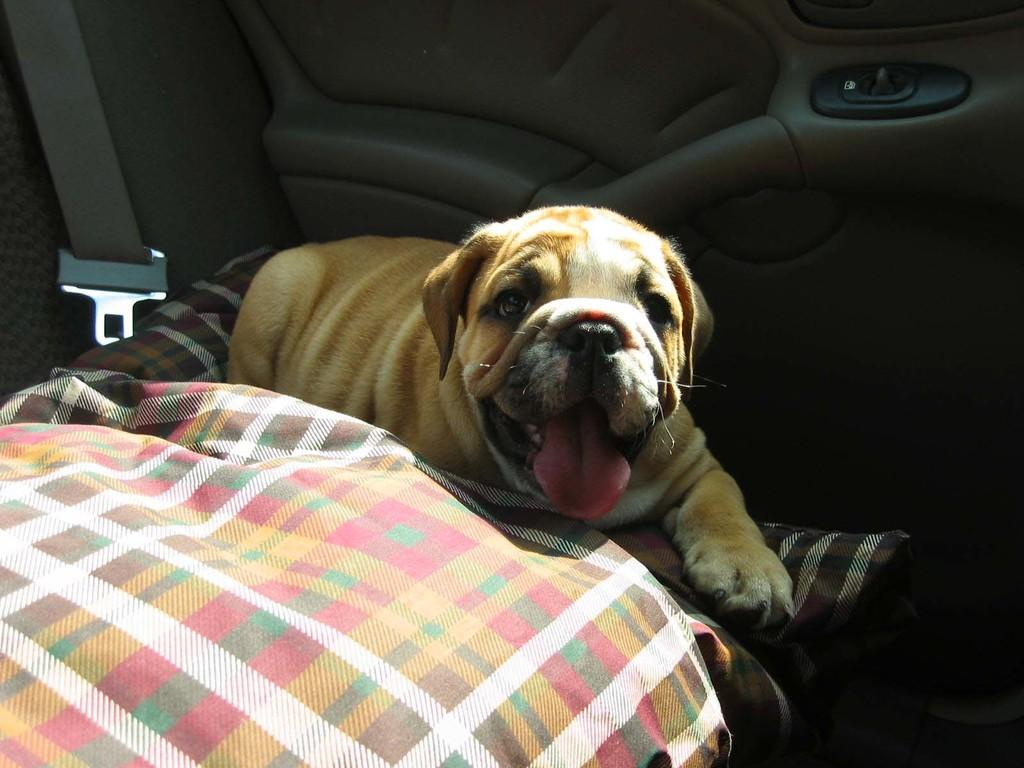What type of animal is in the image? There is a dog in the image. What is on the seat of the car in the image? A cloth is present on the seat of a car in the image. What type of bait is the dog using to catch fish in the ocean in the image? There is no bait, fish, or ocean present in the image; it only features a dog and a cloth on a car seat. 